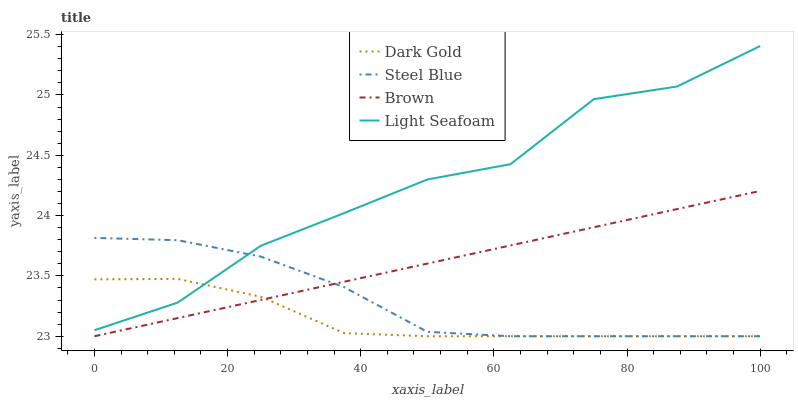Does Dark Gold have the minimum area under the curve?
Answer yes or no. Yes. Does Light Seafoam have the maximum area under the curve?
Answer yes or no. Yes. Does Steel Blue have the minimum area under the curve?
Answer yes or no. No. Does Steel Blue have the maximum area under the curve?
Answer yes or no. No. Is Brown the smoothest?
Answer yes or no. Yes. Is Light Seafoam the roughest?
Answer yes or no. Yes. Is Steel Blue the smoothest?
Answer yes or no. No. Is Steel Blue the roughest?
Answer yes or no. No. Does Brown have the lowest value?
Answer yes or no. Yes. Does Light Seafoam have the lowest value?
Answer yes or no. No. Does Light Seafoam have the highest value?
Answer yes or no. Yes. Does Steel Blue have the highest value?
Answer yes or no. No. Is Brown less than Light Seafoam?
Answer yes or no. Yes. Is Light Seafoam greater than Brown?
Answer yes or no. Yes. Does Brown intersect Steel Blue?
Answer yes or no. Yes. Is Brown less than Steel Blue?
Answer yes or no. No. Is Brown greater than Steel Blue?
Answer yes or no. No. Does Brown intersect Light Seafoam?
Answer yes or no. No. 